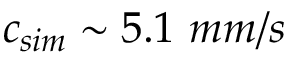Convert formula to latex. <formula><loc_0><loc_0><loc_500><loc_500>c _ { s i m } \sim 5 . 1 m m / s</formula> 